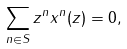<formula> <loc_0><loc_0><loc_500><loc_500>\sum _ { n \in S } z ^ { n } x ^ { n } ( z ) = 0 ,</formula> 